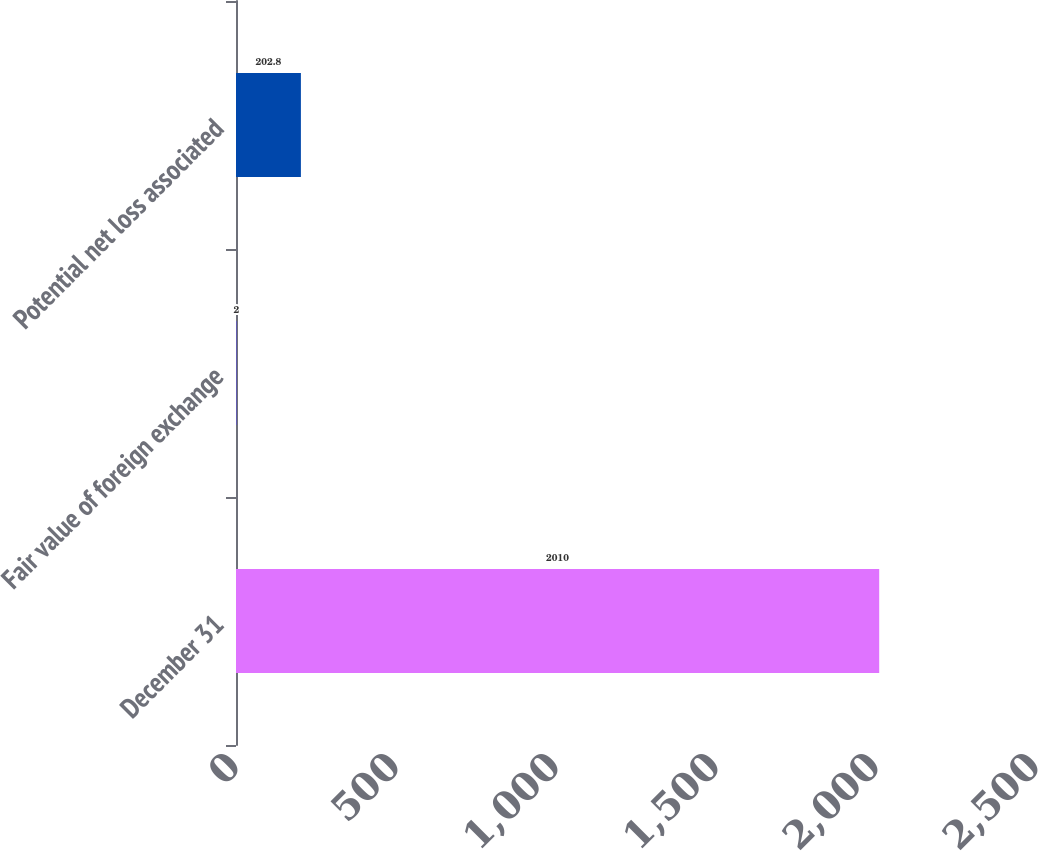Convert chart. <chart><loc_0><loc_0><loc_500><loc_500><bar_chart><fcel>December 31<fcel>Fair value of foreign exchange<fcel>Potential net loss associated<nl><fcel>2010<fcel>2<fcel>202.8<nl></chart> 